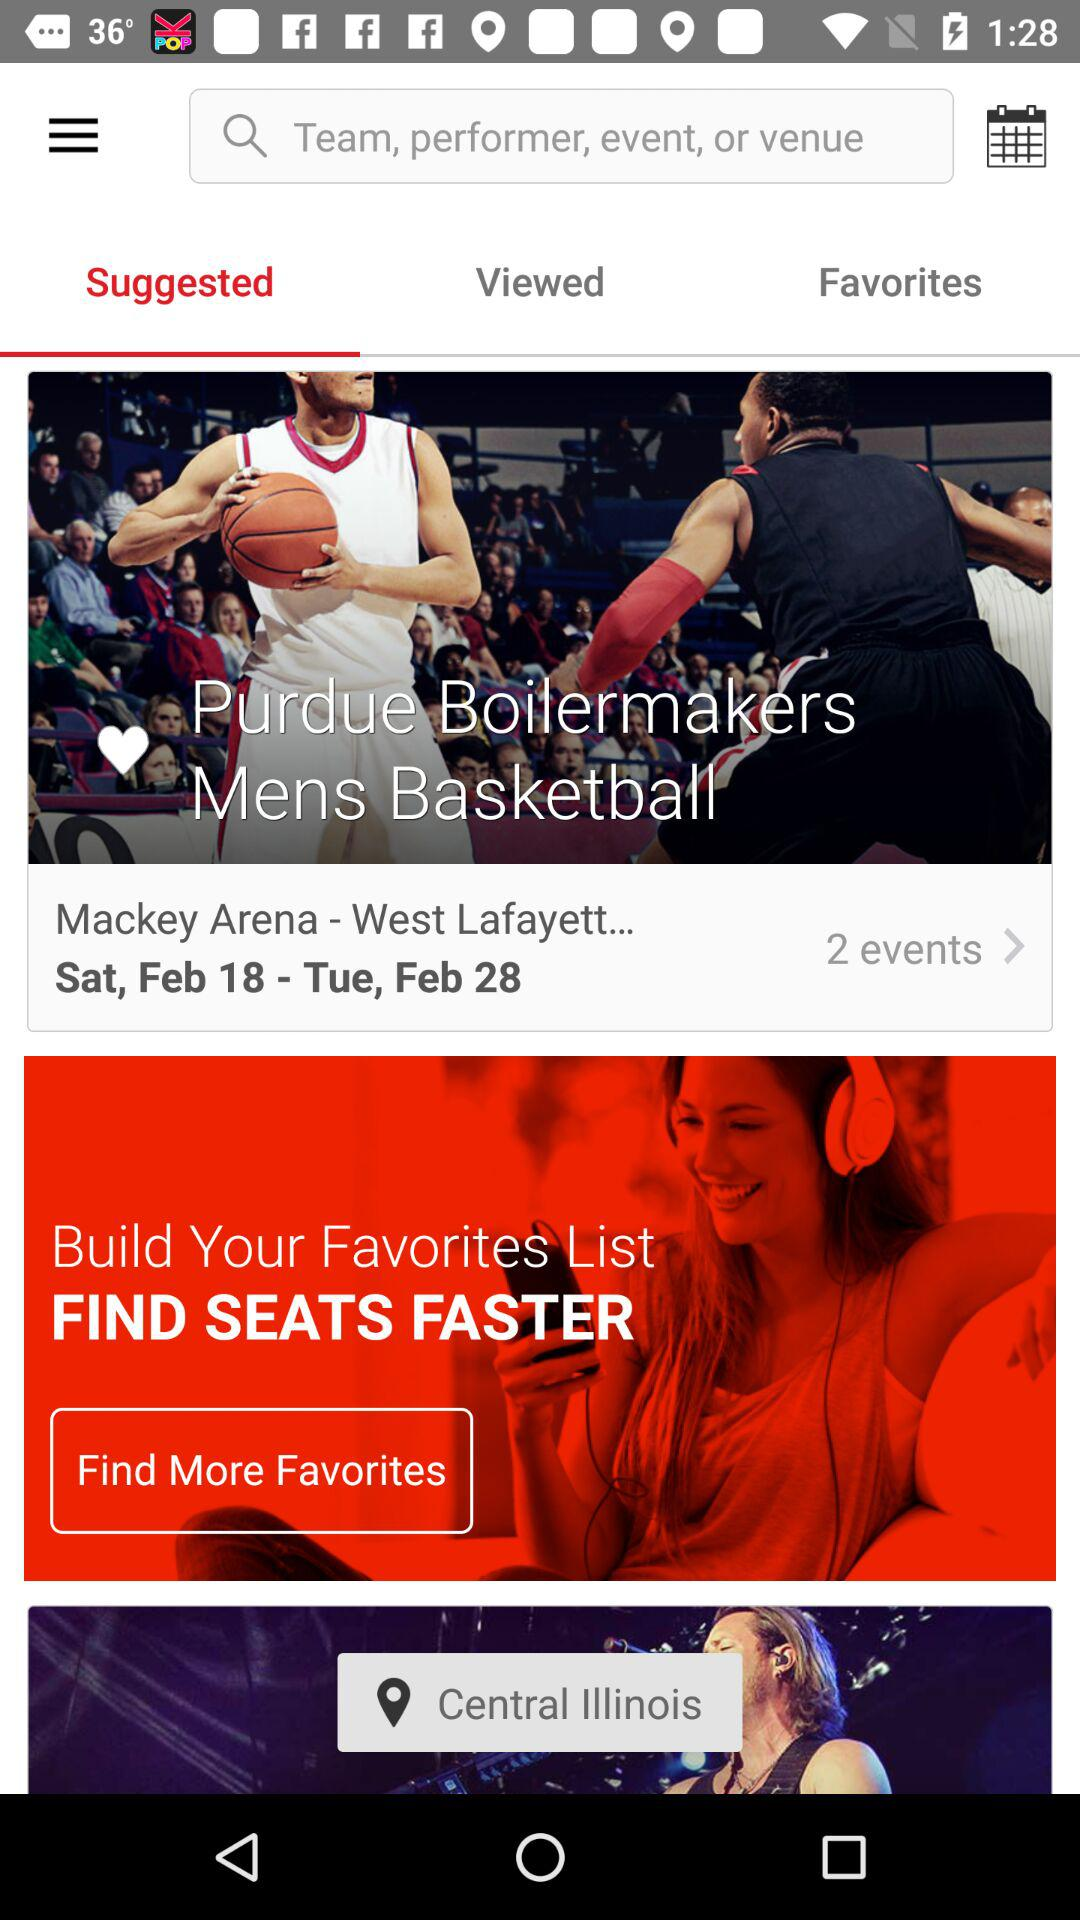What is the date for the "Mackey Arena - West Lafayett..." event? The date for the event is from Saturday, February 18 to Tuesday, February 28. 